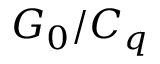<formula> <loc_0><loc_0><loc_500><loc_500>G _ { 0 } / C _ { q }</formula> 